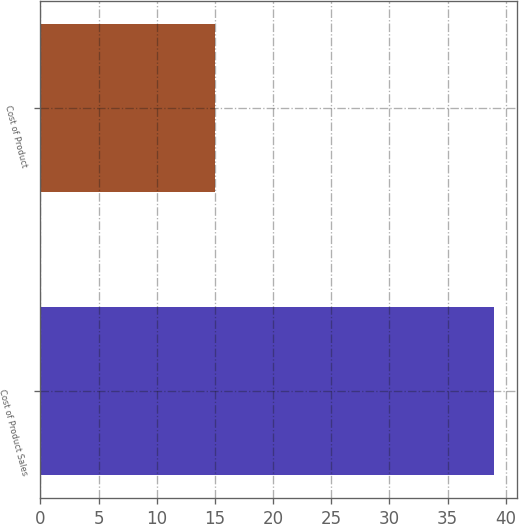Convert chart. <chart><loc_0><loc_0><loc_500><loc_500><bar_chart><fcel>Cost of Product Sales<fcel>Cost of Product<nl><fcel>39<fcel>15<nl></chart> 